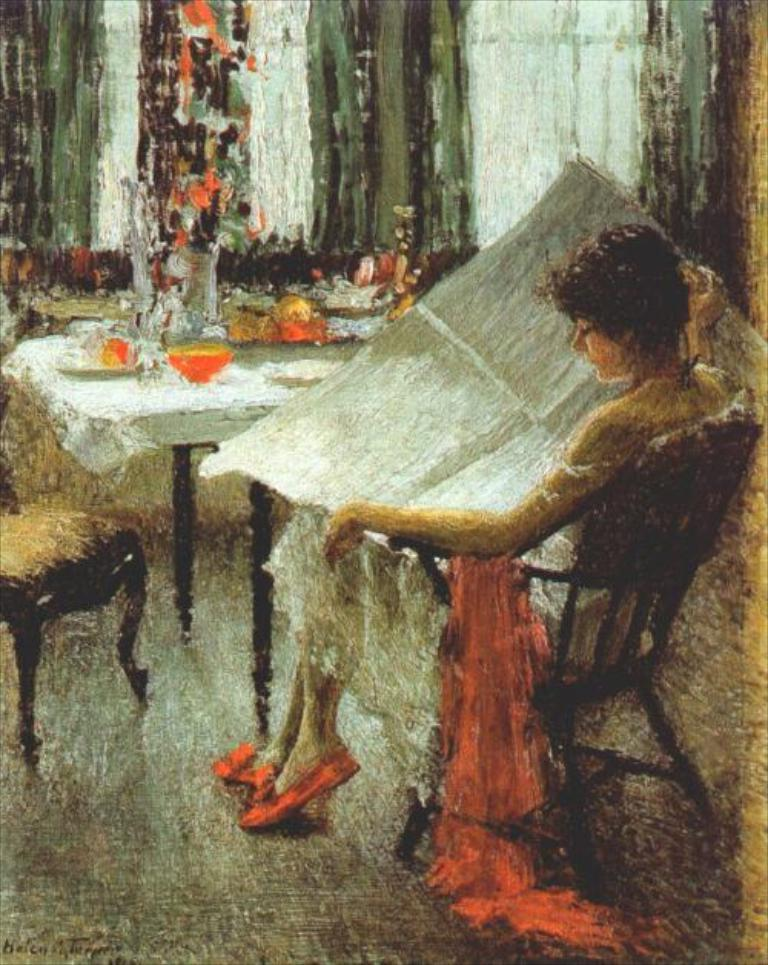What is depicted in the image? There is a painting of a person in the image. What is the person in the painting doing? The person is sitting on a chair in the painting. What is the person holding in the painting? The person is holding a paper in the painting. What is in front of the person in the painting? There is a table in front of the person in the painting. What can be seen on the table in the painting? There are objects on the table in the painting. What type of straw is the person using to drink in the painting? There is no straw present in the painting; the person is holding a paper. 